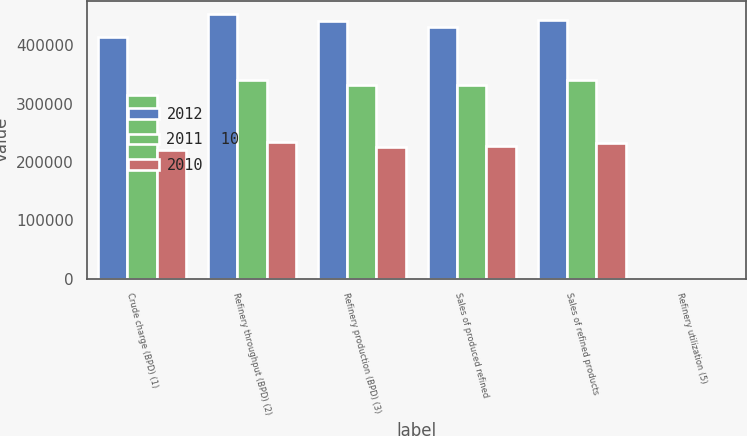Convert chart to OTSL. <chart><loc_0><loc_0><loc_500><loc_500><stacked_bar_chart><ecel><fcel>Crude charge (BPD) (1)<fcel>Refinery throughput (BPD) (2)<fcel>Refinery production (BPD) (3)<fcel>Sales of produced refined<fcel>Sales of refined products<fcel>Refinery utilization (5)<nl><fcel>2012<fcel>415210<fcel>453740<fcel>442730<fcel>431060<fcel>443620<fcel>93.7<nl><fcel>2011  10<fcel>315000<fcel>340200<fcel>331890<fcel>332720<fcel>340630<fcel>89.9<nl><fcel>2010<fcel>221440<fcel>234910<fcel>225980<fcel>228140<fcel>232100<fcel>86.5<nl></chart> 